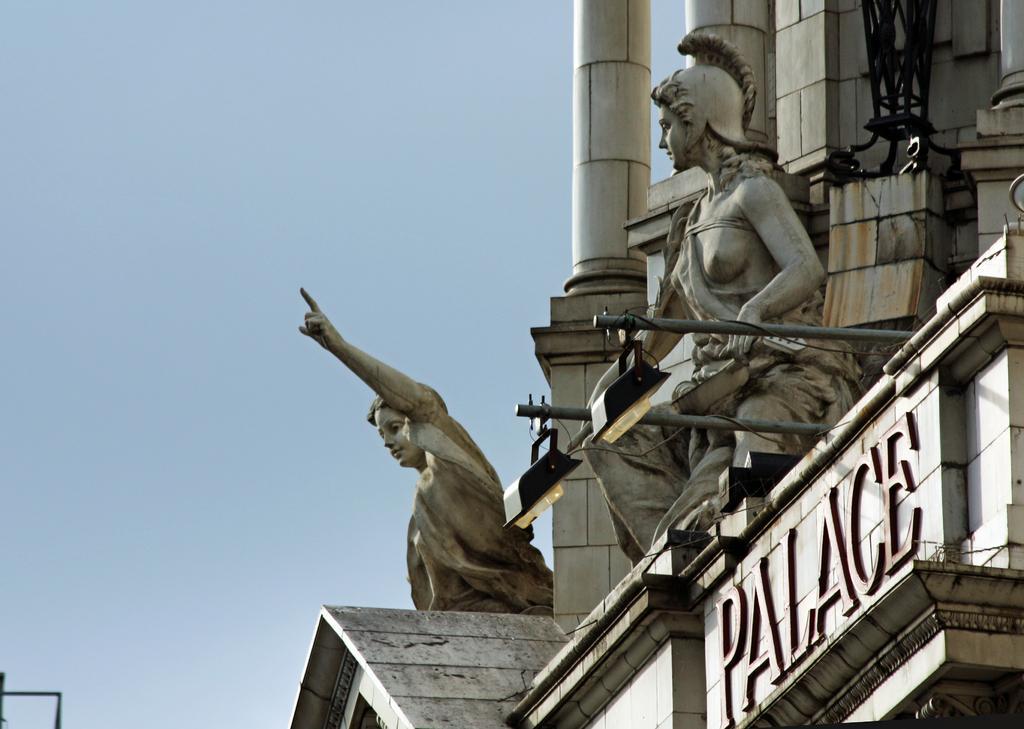Could you give a brief overview of what you see in this image? In this image, I can see a building with sculptures, name board and lights to the poles. In the background, there is the sky. 